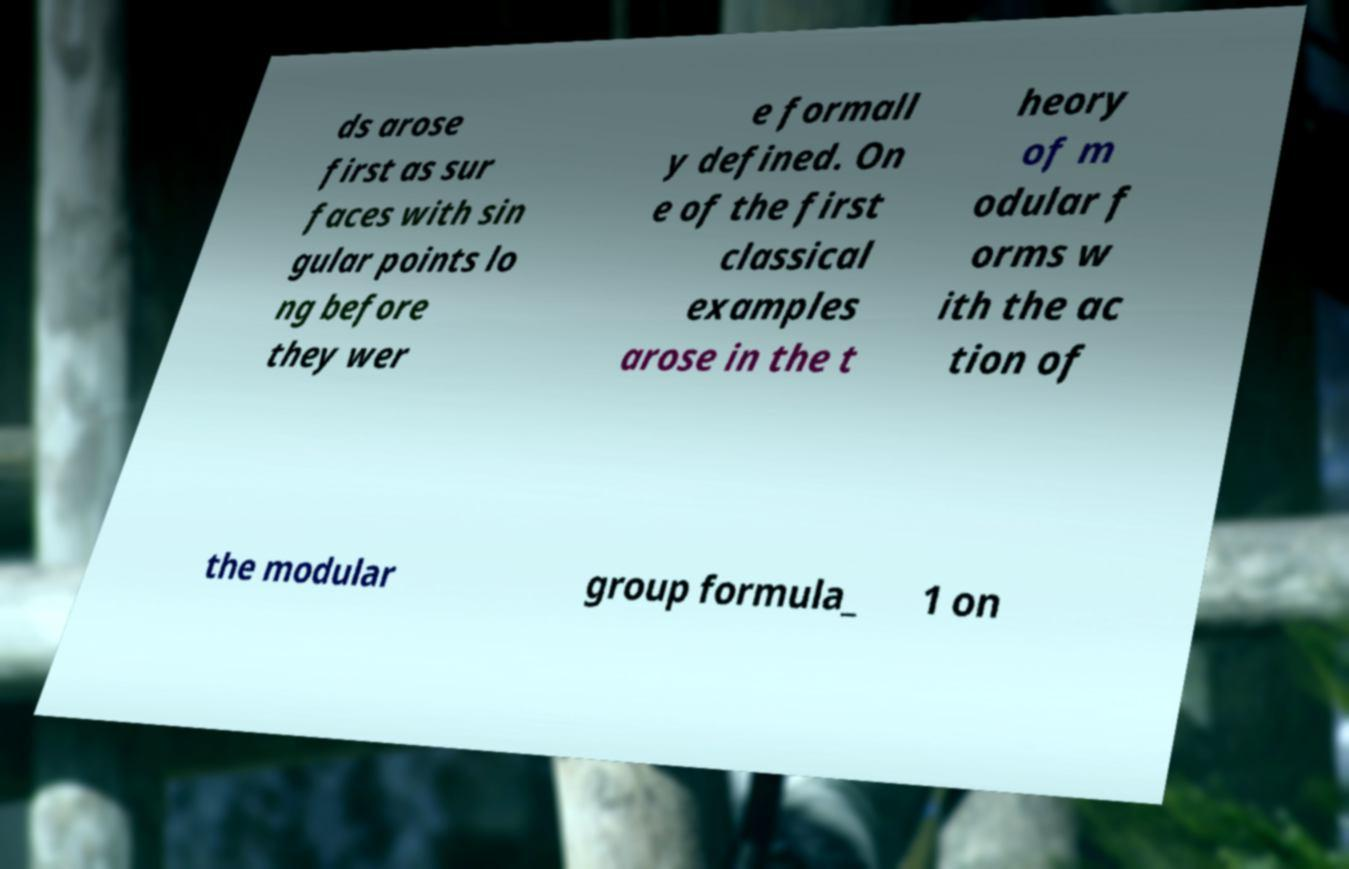I need the written content from this picture converted into text. Can you do that? ds arose first as sur faces with sin gular points lo ng before they wer e formall y defined. On e of the first classical examples arose in the t heory of m odular f orms w ith the ac tion of the modular group formula_ 1 on 